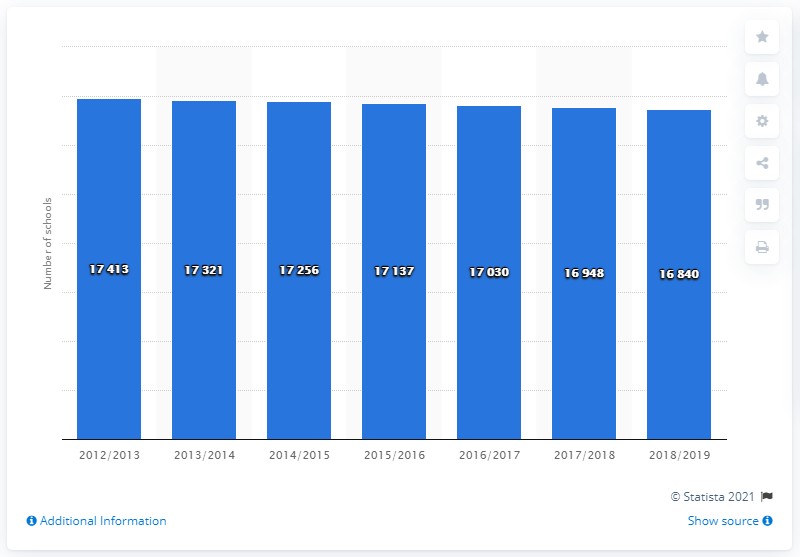List a handful of essential elements in this visual. There were 17,256 primary schools in Italy during the 2012/2013 school year. There were 16,840 elementary schools in Italy during the 2018/2019 school year. 